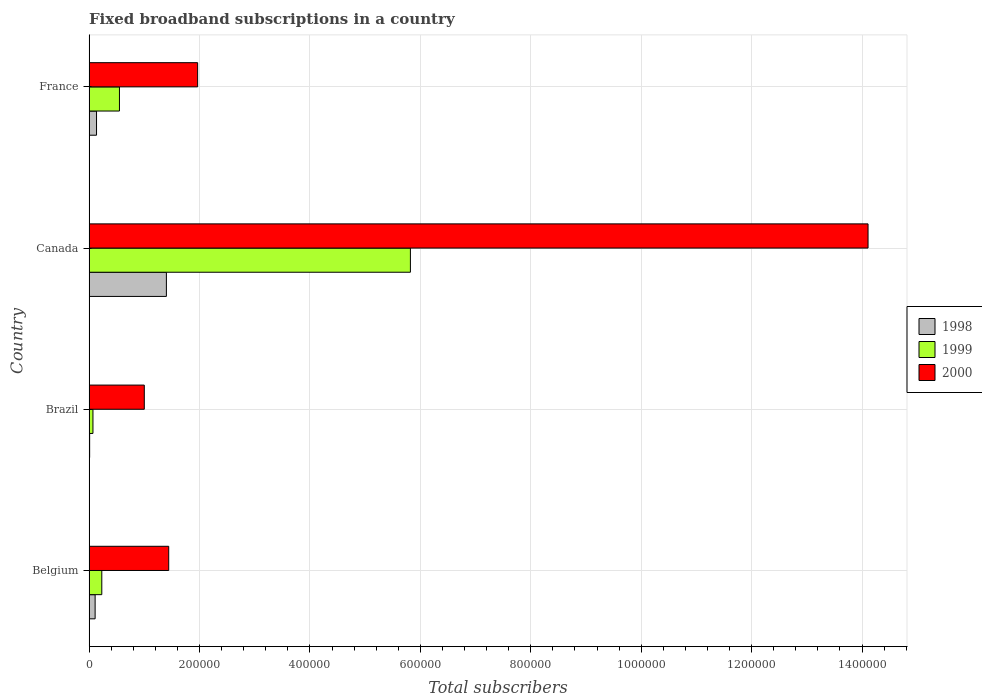How many different coloured bars are there?
Keep it short and to the point. 3. Are the number of bars per tick equal to the number of legend labels?
Your answer should be compact. Yes. How many bars are there on the 4th tick from the top?
Give a very brief answer. 3. What is the label of the 1st group of bars from the top?
Provide a succinct answer. France. What is the number of broadband subscriptions in 2000 in Belgium?
Keep it short and to the point. 1.44e+05. Across all countries, what is the maximum number of broadband subscriptions in 2000?
Your answer should be very brief. 1.41e+06. In which country was the number of broadband subscriptions in 2000 maximum?
Ensure brevity in your answer.  Canada. What is the total number of broadband subscriptions in 1998 in the graph?
Your response must be concise. 1.65e+05. What is the difference between the number of broadband subscriptions in 1999 in Brazil and that in Canada?
Your response must be concise. -5.75e+05. What is the difference between the number of broadband subscriptions in 1998 in Canada and the number of broadband subscriptions in 2000 in Brazil?
Your response must be concise. 4.00e+04. What is the average number of broadband subscriptions in 2000 per country?
Give a very brief answer. 4.63e+05. What is the difference between the number of broadband subscriptions in 2000 and number of broadband subscriptions in 1999 in Canada?
Your answer should be compact. 8.29e+05. What is the ratio of the number of broadband subscriptions in 2000 in Brazil to that in Canada?
Your answer should be compact. 0.07. Is the number of broadband subscriptions in 1998 in Belgium less than that in Brazil?
Keep it short and to the point. No. What is the difference between the highest and the second highest number of broadband subscriptions in 2000?
Offer a terse response. 1.21e+06. What is the difference between the highest and the lowest number of broadband subscriptions in 2000?
Give a very brief answer. 1.31e+06. Is the sum of the number of broadband subscriptions in 2000 in Brazil and France greater than the maximum number of broadband subscriptions in 1998 across all countries?
Your answer should be compact. Yes. Is it the case that in every country, the sum of the number of broadband subscriptions in 1999 and number of broadband subscriptions in 2000 is greater than the number of broadband subscriptions in 1998?
Give a very brief answer. Yes. How many countries are there in the graph?
Provide a succinct answer. 4. What is the difference between two consecutive major ticks on the X-axis?
Your answer should be compact. 2.00e+05. Are the values on the major ticks of X-axis written in scientific E-notation?
Your answer should be compact. No. Does the graph contain any zero values?
Provide a succinct answer. No. Does the graph contain grids?
Offer a very short reply. Yes. What is the title of the graph?
Offer a terse response. Fixed broadband subscriptions in a country. Does "1968" appear as one of the legend labels in the graph?
Offer a terse response. No. What is the label or title of the X-axis?
Ensure brevity in your answer.  Total subscribers. What is the Total subscribers of 1998 in Belgium?
Your response must be concise. 1.09e+04. What is the Total subscribers of 1999 in Belgium?
Provide a succinct answer. 2.30e+04. What is the Total subscribers in 2000 in Belgium?
Keep it short and to the point. 1.44e+05. What is the Total subscribers of 1998 in Brazil?
Make the answer very short. 1000. What is the Total subscribers in 1999 in Brazil?
Provide a succinct answer. 7000. What is the Total subscribers in 1999 in Canada?
Give a very brief answer. 5.82e+05. What is the Total subscribers in 2000 in Canada?
Offer a terse response. 1.41e+06. What is the Total subscribers in 1998 in France?
Ensure brevity in your answer.  1.35e+04. What is the Total subscribers of 1999 in France?
Provide a succinct answer. 5.50e+04. What is the Total subscribers of 2000 in France?
Offer a very short reply. 1.97e+05. Across all countries, what is the maximum Total subscribers of 1999?
Provide a succinct answer. 5.82e+05. Across all countries, what is the maximum Total subscribers of 2000?
Make the answer very short. 1.41e+06. Across all countries, what is the minimum Total subscribers of 1999?
Your response must be concise. 7000. Across all countries, what is the minimum Total subscribers of 2000?
Provide a succinct answer. 1.00e+05. What is the total Total subscribers in 1998 in the graph?
Ensure brevity in your answer.  1.65e+05. What is the total Total subscribers in 1999 in the graph?
Provide a succinct answer. 6.67e+05. What is the total Total subscribers in 2000 in the graph?
Provide a succinct answer. 1.85e+06. What is the difference between the Total subscribers of 1998 in Belgium and that in Brazil?
Ensure brevity in your answer.  9924. What is the difference between the Total subscribers in 1999 in Belgium and that in Brazil?
Ensure brevity in your answer.  1.60e+04. What is the difference between the Total subscribers in 2000 in Belgium and that in Brazil?
Your response must be concise. 4.42e+04. What is the difference between the Total subscribers in 1998 in Belgium and that in Canada?
Your answer should be compact. -1.29e+05. What is the difference between the Total subscribers in 1999 in Belgium and that in Canada?
Your answer should be very brief. -5.59e+05. What is the difference between the Total subscribers of 2000 in Belgium and that in Canada?
Keep it short and to the point. -1.27e+06. What is the difference between the Total subscribers in 1998 in Belgium and that in France?
Give a very brief answer. -2540. What is the difference between the Total subscribers in 1999 in Belgium and that in France?
Keep it short and to the point. -3.20e+04. What is the difference between the Total subscribers of 2000 in Belgium and that in France?
Make the answer very short. -5.24e+04. What is the difference between the Total subscribers in 1998 in Brazil and that in Canada?
Give a very brief answer. -1.39e+05. What is the difference between the Total subscribers in 1999 in Brazil and that in Canada?
Give a very brief answer. -5.75e+05. What is the difference between the Total subscribers of 2000 in Brazil and that in Canada?
Provide a short and direct response. -1.31e+06. What is the difference between the Total subscribers in 1998 in Brazil and that in France?
Keep it short and to the point. -1.25e+04. What is the difference between the Total subscribers of 1999 in Brazil and that in France?
Offer a very short reply. -4.80e+04. What is the difference between the Total subscribers of 2000 in Brazil and that in France?
Your answer should be compact. -9.66e+04. What is the difference between the Total subscribers of 1998 in Canada and that in France?
Your answer should be very brief. 1.27e+05. What is the difference between the Total subscribers of 1999 in Canada and that in France?
Offer a very short reply. 5.27e+05. What is the difference between the Total subscribers in 2000 in Canada and that in France?
Provide a succinct answer. 1.21e+06. What is the difference between the Total subscribers in 1998 in Belgium and the Total subscribers in 1999 in Brazil?
Provide a short and direct response. 3924. What is the difference between the Total subscribers in 1998 in Belgium and the Total subscribers in 2000 in Brazil?
Ensure brevity in your answer.  -8.91e+04. What is the difference between the Total subscribers of 1999 in Belgium and the Total subscribers of 2000 in Brazil?
Ensure brevity in your answer.  -7.70e+04. What is the difference between the Total subscribers in 1998 in Belgium and the Total subscribers in 1999 in Canada?
Your response must be concise. -5.71e+05. What is the difference between the Total subscribers of 1998 in Belgium and the Total subscribers of 2000 in Canada?
Provide a short and direct response. -1.40e+06. What is the difference between the Total subscribers of 1999 in Belgium and the Total subscribers of 2000 in Canada?
Your answer should be very brief. -1.39e+06. What is the difference between the Total subscribers of 1998 in Belgium and the Total subscribers of 1999 in France?
Your answer should be compact. -4.41e+04. What is the difference between the Total subscribers in 1998 in Belgium and the Total subscribers in 2000 in France?
Ensure brevity in your answer.  -1.86e+05. What is the difference between the Total subscribers in 1999 in Belgium and the Total subscribers in 2000 in France?
Your answer should be compact. -1.74e+05. What is the difference between the Total subscribers of 1998 in Brazil and the Total subscribers of 1999 in Canada?
Your answer should be compact. -5.81e+05. What is the difference between the Total subscribers of 1998 in Brazil and the Total subscribers of 2000 in Canada?
Ensure brevity in your answer.  -1.41e+06. What is the difference between the Total subscribers in 1999 in Brazil and the Total subscribers in 2000 in Canada?
Keep it short and to the point. -1.40e+06. What is the difference between the Total subscribers in 1998 in Brazil and the Total subscribers in 1999 in France?
Offer a terse response. -5.40e+04. What is the difference between the Total subscribers in 1998 in Brazil and the Total subscribers in 2000 in France?
Give a very brief answer. -1.96e+05. What is the difference between the Total subscribers of 1999 in Brazil and the Total subscribers of 2000 in France?
Your answer should be compact. -1.90e+05. What is the difference between the Total subscribers of 1998 in Canada and the Total subscribers of 1999 in France?
Ensure brevity in your answer.  8.50e+04. What is the difference between the Total subscribers in 1998 in Canada and the Total subscribers in 2000 in France?
Give a very brief answer. -5.66e+04. What is the difference between the Total subscribers in 1999 in Canada and the Total subscribers in 2000 in France?
Keep it short and to the point. 3.85e+05. What is the average Total subscribers in 1998 per country?
Offer a very short reply. 4.13e+04. What is the average Total subscribers in 1999 per country?
Provide a succinct answer. 1.67e+05. What is the average Total subscribers in 2000 per country?
Provide a succinct answer. 4.63e+05. What is the difference between the Total subscribers of 1998 and Total subscribers of 1999 in Belgium?
Give a very brief answer. -1.21e+04. What is the difference between the Total subscribers in 1998 and Total subscribers in 2000 in Belgium?
Your answer should be compact. -1.33e+05. What is the difference between the Total subscribers of 1999 and Total subscribers of 2000 in Belgium?
Give a very brief answer. -1.21e+05. What is the difference between the Total subscribers in 1998 and Total subscribers in 1999 in Brazil?
Make the answer very short. -6000. What is the difference between the Total subscribers in 1998 and Total subscribers in 2000 in Brazil?
Keep it short and to the point. -9.90e+04. What is the difference between the Total subscribers in 1999 and Total subscribers in 2000 in Brazil?
Your answer should be compact. -9.30e+04. What is the difference between the Total subscribers of 1998 and Total subscribers of 1999 in Canada?
Ensure brevity in your answer.  -4.42e+05. What is the difference between the Total subscribers in 1998 and Total subscribers in 2000 in Canada?
Your response must be concise. -1.27e+06. What is the difference between the Total subscribers of 1999 and Total subscribers of 2000 in Canada?
Your answer should be compact. -8.29e+05. What is the difference between the Total subscribers in 1998 and Total subscribers in 1999 in France?
Offer a terse response. -4.15e+04. What is the difference between the Total subscribers in 1998 and Total subscribers in 2000 in France?
Make the answer very short. -1.83e+05. What is the difference between the Total subscribers of 1999 and Total subscribers of 2000 in France?
Ensure brevity in your answer.  -1.42e+05. What is the ratio of the Total subscribers of 1998 in Belgium to that in Brazil?
Provide a succinct answer. 10.92. What is the ratio of the Total subscribers in 1999 in Belgium to that in Brazil?
Your answer should be very brief. 3.29. What is the ratio of the Total subscribers in 2000 in Belgium to that in Brazil?
Provide a succinct answer. 1.44. What is the ratio of the Total subscribers of 1998 in Belgium to that in Canada?
Keep it short and to the point. 0.08. What is the ratio of the Total subscribers in 1999 in Belgium to that in Canada?
Provide a succinct answer. 0.04. What is the ratio of the Total subscribers of 2000 in Belgium to that in Canada?
Give a very brief answer. 0.1. What is the ratio of the Total subscribers of 1998 in Belgium to that in France?
Ensure brevity in your answer.  0.81. What is the ratio of the Total subscribers of 1999 in Belgium to that in France?
Provide a succinct answer. 0.42. What is the ratio of the Total subscribers in 2000 in Belgium to that in France?
Offer a terse response. 0.73. What is the ratio of the Total subscribers of 1998 in Brazil to that in Canada?
Your answer should be very brief. 0.01. What is the ratio of the Total subscribers in 1999 in Brazil to that in Canada?
Offer a terse response. 0.01. What is the ratio of the Total subscribers of 2000 in Brazil to that in Canada?
Keep it short and to the point. 0.07. What is the ratio of the Total subscribers of 1998 in Brazil to that in France?
Offer a terse response. 0.07. What is the ratio of the Total subscribers of 1999 in Brazil to that in France?
Ensure brevity in your answer.  0.13. What is the ratio of the Total subscribers of 2000 in Brazil to that in France?
Your answer should be very brief. 0.51. What is the ratio of the Total subscribers in 1998 in Canada to that in France?
Provide a succinct answer. 10.4. What is the ratio of the Total subscribers of 1999 in Canada to that in France?
Your answer should be compact. 10.58. What is the ratio of the Total subscribers of 2000 in Canada to that in France?
Make the answer very short. 7.18. What is the difference between the highest and the second highest Total subscribers in 1998?
Ensure brevity in your answer.  1.27e+05. What is the difference between the highest and the second highest Total subscribers of 1999?
Make the answer very short. 5.27e+05. What is the difference between the highest and the second highest Total subscribers in 2000?
Make the answer very short. 1.21e+06. What is the difference between the highest and the lowest Total subscribers of 1998?
Provide a succinct answer. 1.39e+05. What is the difference between the highest and the lowest Total subscribers in 1999?
Provide a short and direct response. 5.75e+05. What is the difference between the highest and the lowest Total subscribers in 2000?
Your response must be concise. 1.31e+06. 